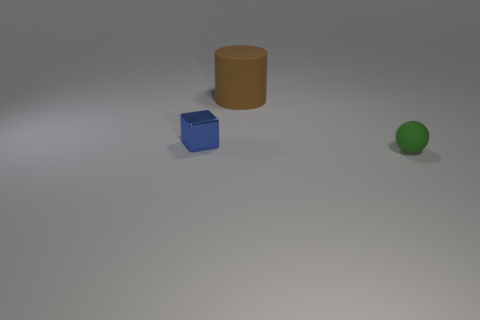Add 3 blue cylinders. How many objects exist? 6 Subtract all cylinders. How many objects are left? 2 Add 2 blue balls. How many blue balls exist? 2 Subtract 0 cyan cylinders. How many objects are left? 3 Subtract all tiny shiny blocks. Subtract all matte objects. How many objects are left? 0 Add 2 tiny blue metallic cubes. How many tiny blue metallic cubes are left? 3 